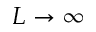Convert formula to latex. <formula><loc_0><loc_0><loc_500><loc_500>L \to \infty</formula> 